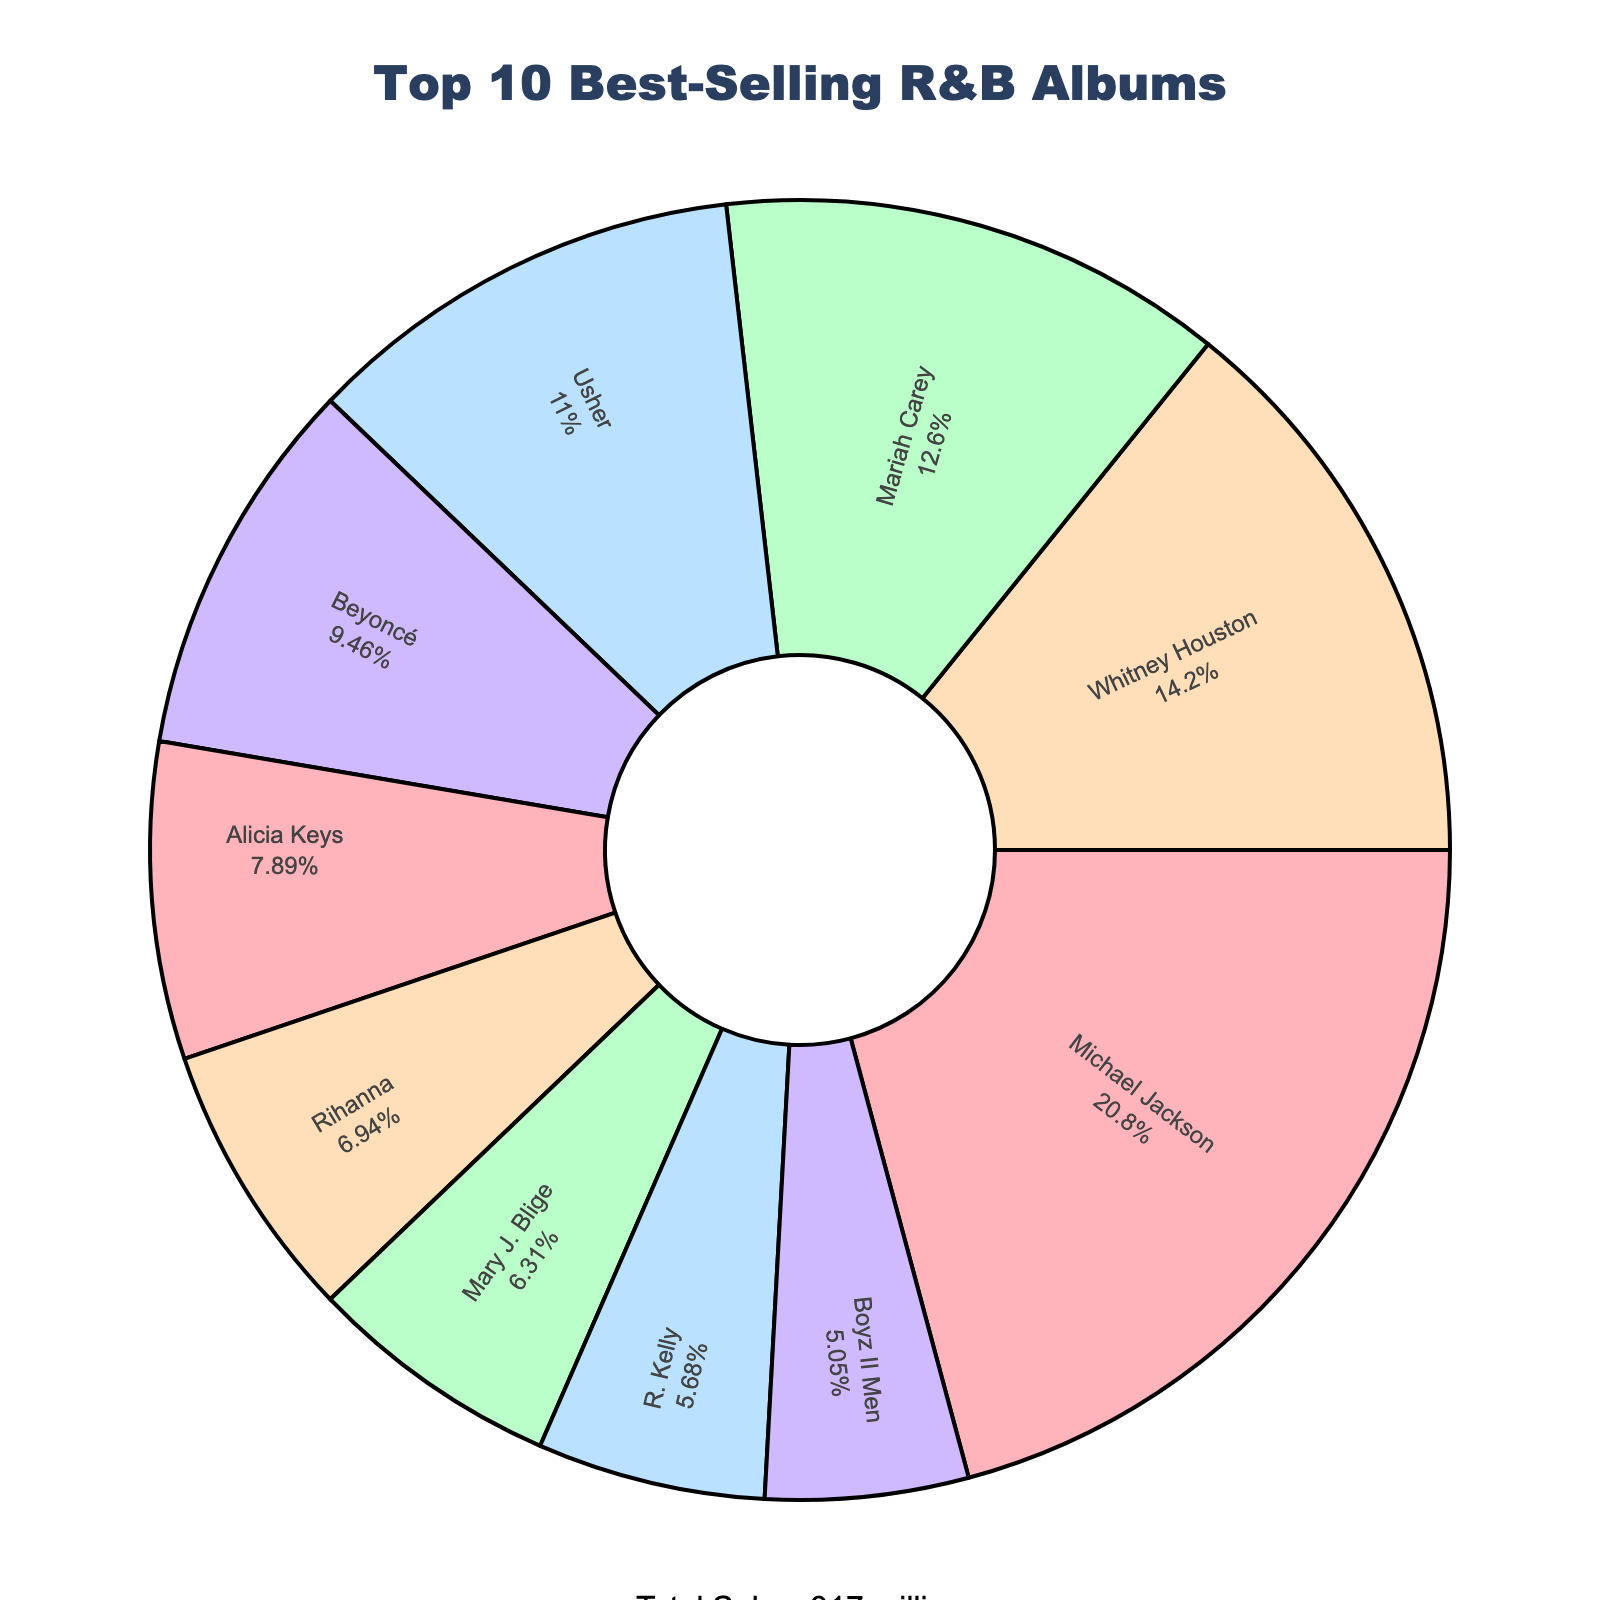What percentage of total sales did Michael Jackson's album contribute? To find the percentage of total sales contributed by Michael Jackson, check the segment labeled "Michael Jackson" on the pie chart and note the percentage provided inside the segment.
Answer: 30% Which artist has the smallest segment, and what is their sales figure? The smallest segment on the pie chart represents Boyz II Men. According to the data, their sales figure is 16 million.
Answer: Boyz II Men, 16 million How do the combined sales of Usher and Beyoncé compare to Michael Jackson's sales? Sum Usher's and Beyoncé's sales: 35 + 30 = 65 million. Michael Jackson's sales are 66 million. So, Michael Jackson's sales are 1 million more than the combined sales of Usher and Beyoncé.
Answer: Michael Jackson's sales are 1 million higher What is the total sales contribution of artists with sales less than 25 million? The relevant artists are Rihanna, Mary J. Blige, R. Kelly, and Boyz II Men. Sum their sales: 22 + 20 + 18 + 16 = 76 million.
Answer: 76 million Which artist has the highest sales, and what is their exact sales figure? The largest segment belongs to Michael Jackson. His sales figure is 66 million.
Answer: Michael Jackson, 66 million Who has a larger share of the pie chart, Mariah Carey or Usher, and by how much? Check the sizes of the segments labeled "Mariah Carey" and "Usher." Mariah Carey's segment is larger. Subtract Usher's sales from Mariah Carey's sales: 40 - 35 = 5 million.
Answer: Mariah Carey by 5 million What's the median sales figure among the top 10 artists? Sort the sales list: [16, 18, 20, 22, 25, 30, 35, 40, 45, 66]. The median value, the fifth data point in an ordered even set, is the average of the 5th and 6th values: (25 + 30) / 2 = 27.5 million.
Answer: 27.5 million 